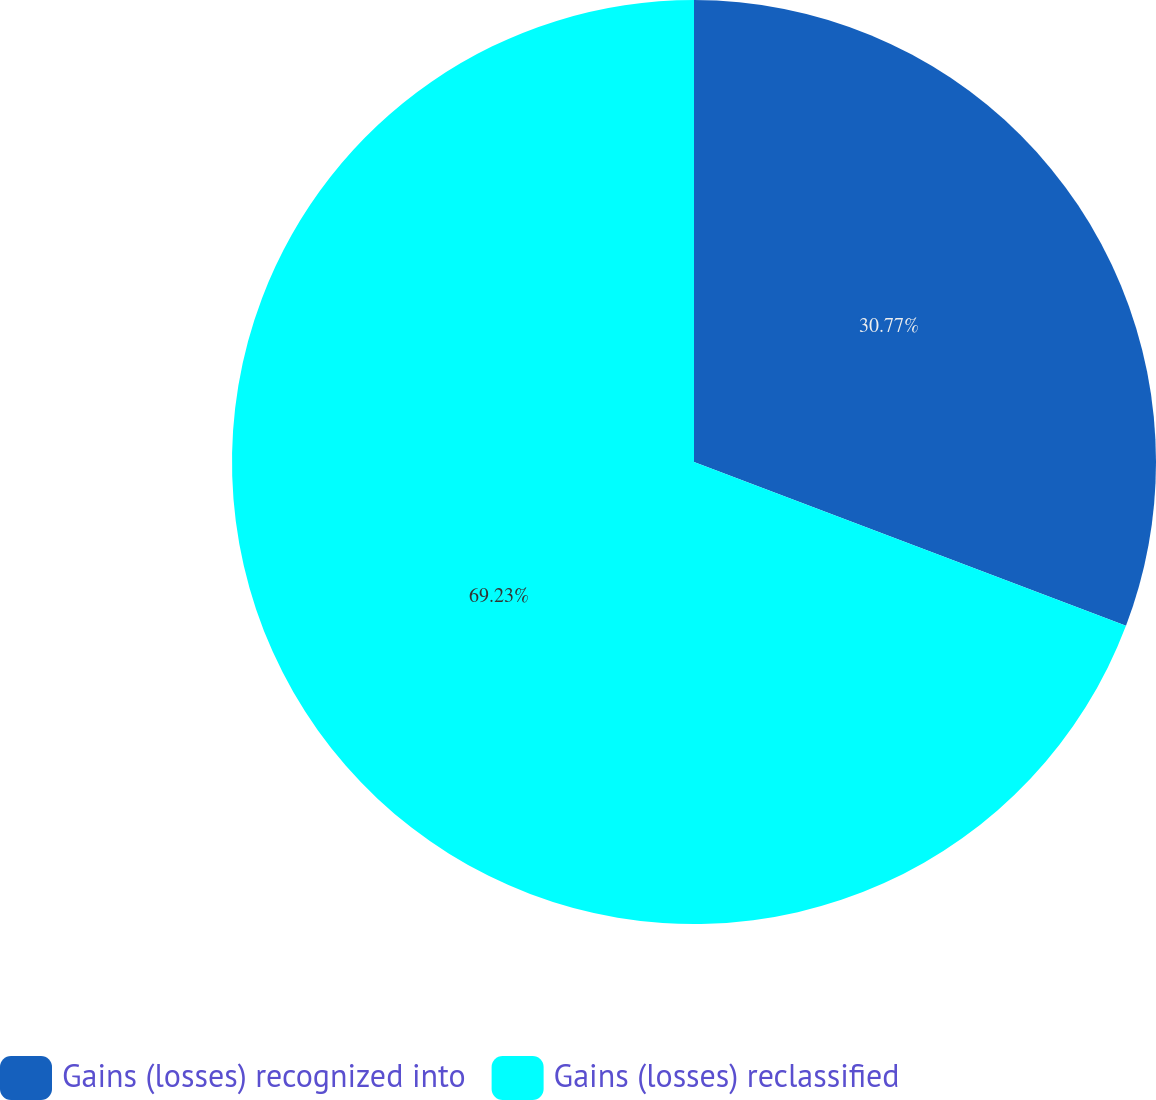Convert chart to OTSL. <chart><loc_0><loc_0><loc_500><loc_500><pie_chart><fcel>Gains (losses) recognized into<fcel>Gains (losses) reclassified<nl><fcel>30.77%<fcel>69.23%<nl></chart> 